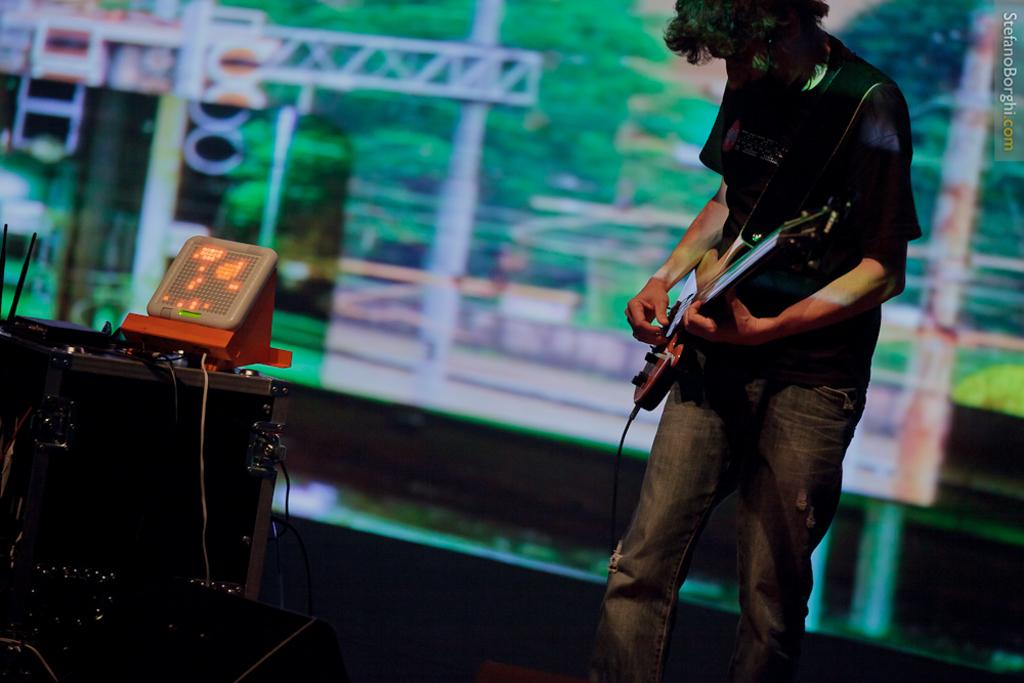What is the man in the image doing? The man is playing a guitar in the image. What object can be seen besides the man in the image? There is a machine in the image. What type of spy equipment can be seen in the image? There is no spy equipment present in the image; it features a man playing a guitar and a machine. What kind of structure is visible in the image? There is no structure visible in the image; it only shows a man playing a guitar and a machine. 